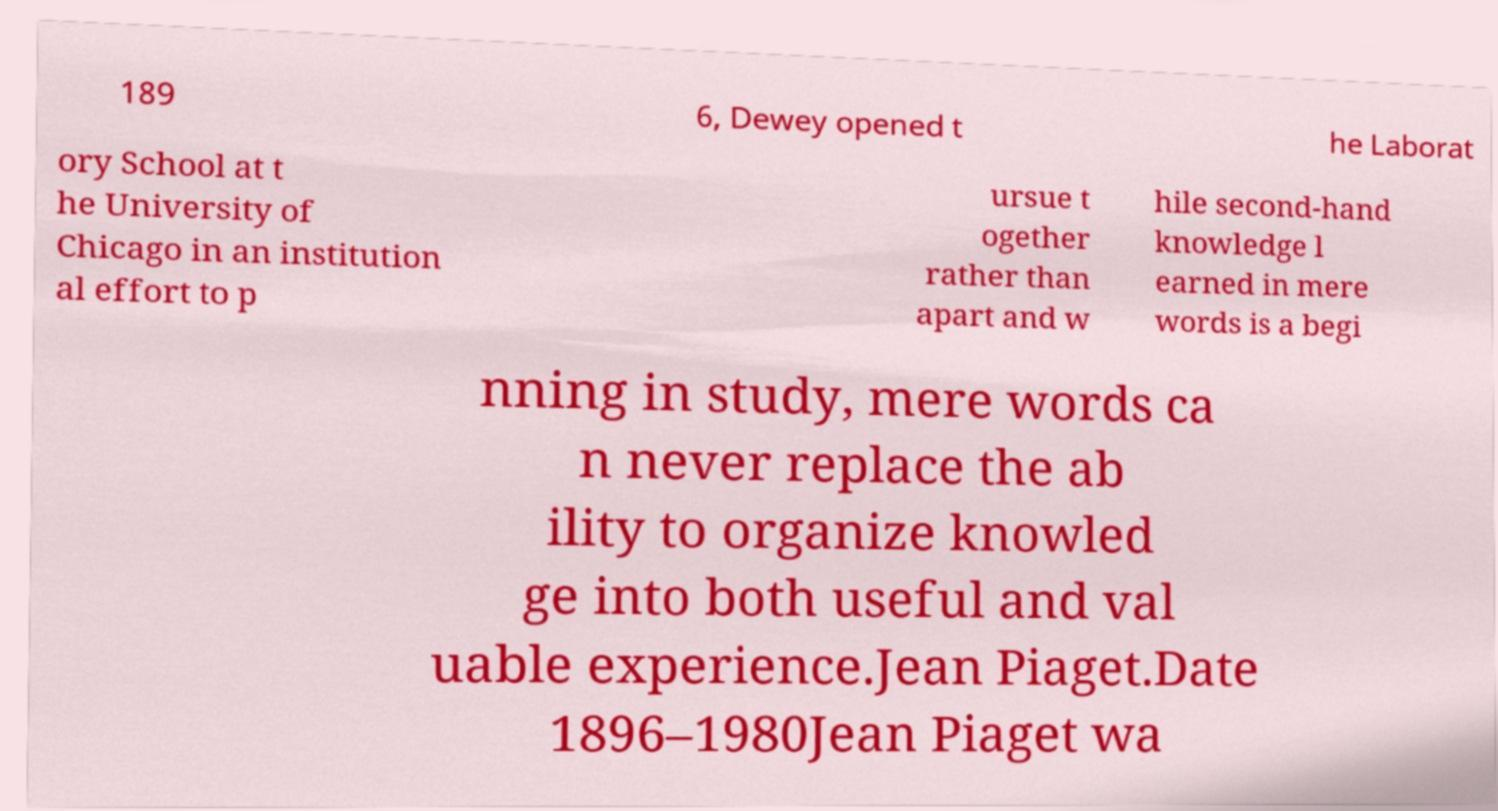Please read and relay the text visible in this image. What does it say? 189 6, Dewey opened t he Laborat ory School at t he University of Chicago in an institution al effort to p ursue t ogether rather than apart and w hile second-hand knowledge l earned in mere words is a begi nning in study, mere words ca n never replace the ab ility to organize knowled ge into both useful and val uable experience.Jean Piaget.Date 1896–1980Jean Piaget wa 